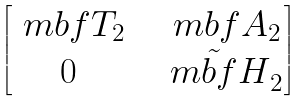Convert formula to latex. <formula><loc_0><loc_0><loc_500><loc_500>\begin{bmatrix} \ m b f { T } _ { 2 } & & \ m b f { A } _ { 2 } \\ 0 & & \tilde { \ m b f { H } } _ { 2 } \end{bmatrix}</formula> 